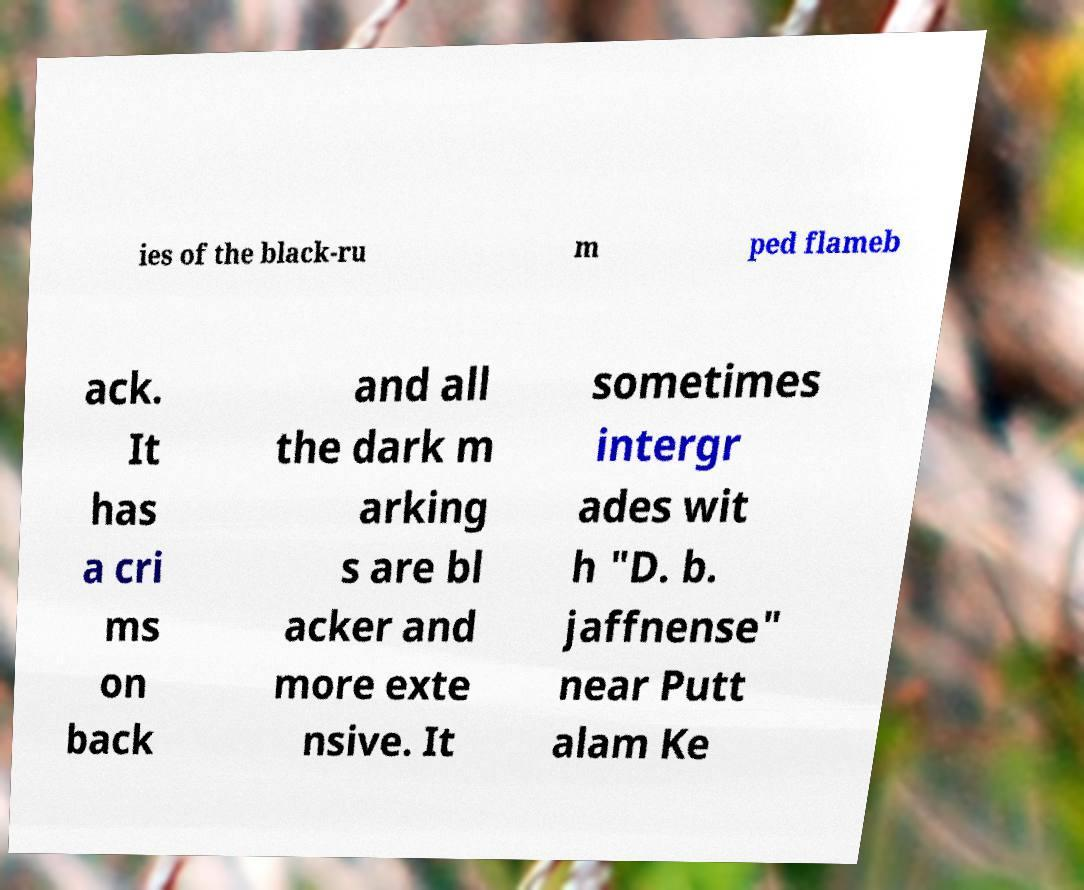For documentation purposes, I need the text within this image transcribed. Could you provide that? ies of the black-ru m ped flameb ack. It has a cri ms on back and all the dark m arking s are bl acker and more exte nsive. It sometimes intergr ades wit h "D. b. jaffnense" near Putt alam Ke 